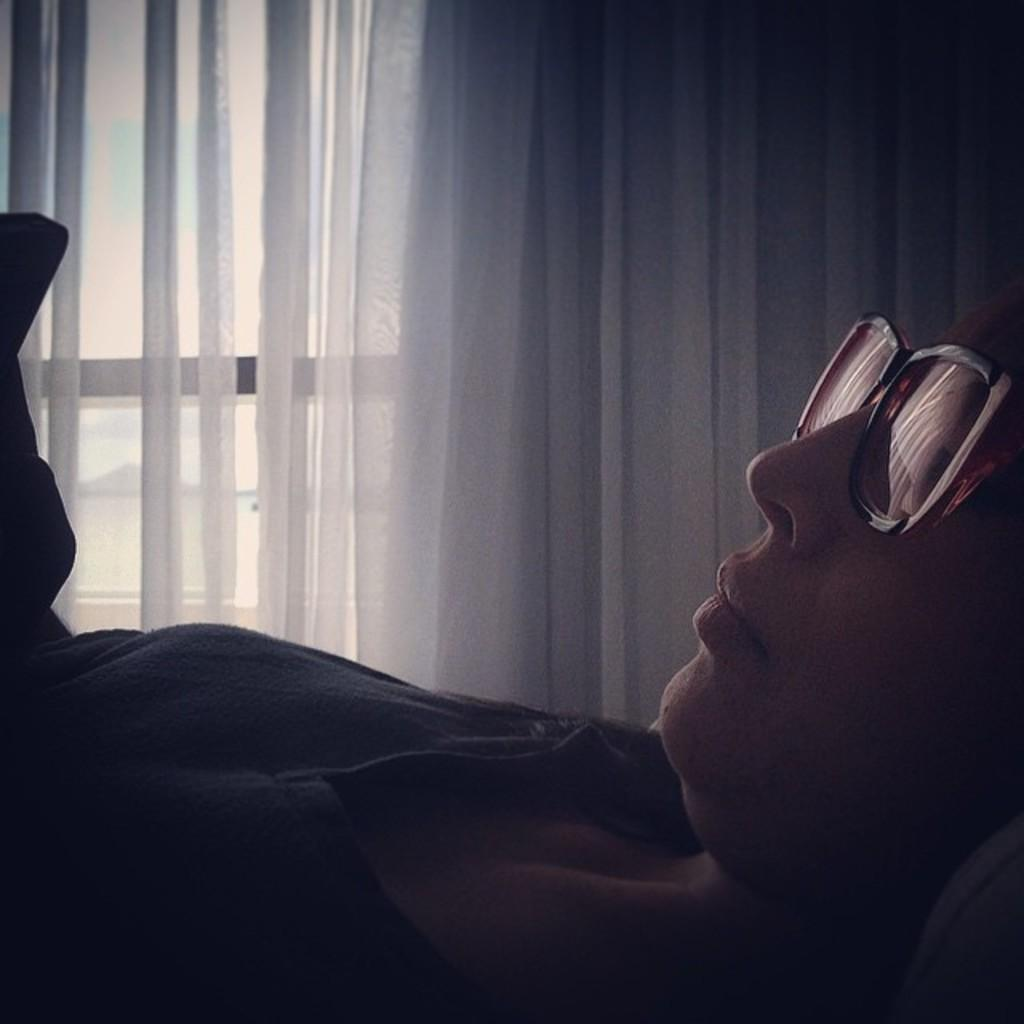Who or what is in the image? There is a person in the image. Where is the person located in relation to the window? The person is beside a window. What accessory is the person wearing? The person is wearing sunglasses. What type of feather can be seen on the person's hat in the image? There is no hat or feather present in the image; the person is wearing sunglasses. What camping equipment is visible in the image? There is no camping equipment present in the image; it features a person beside a window wearing sunglasses. 